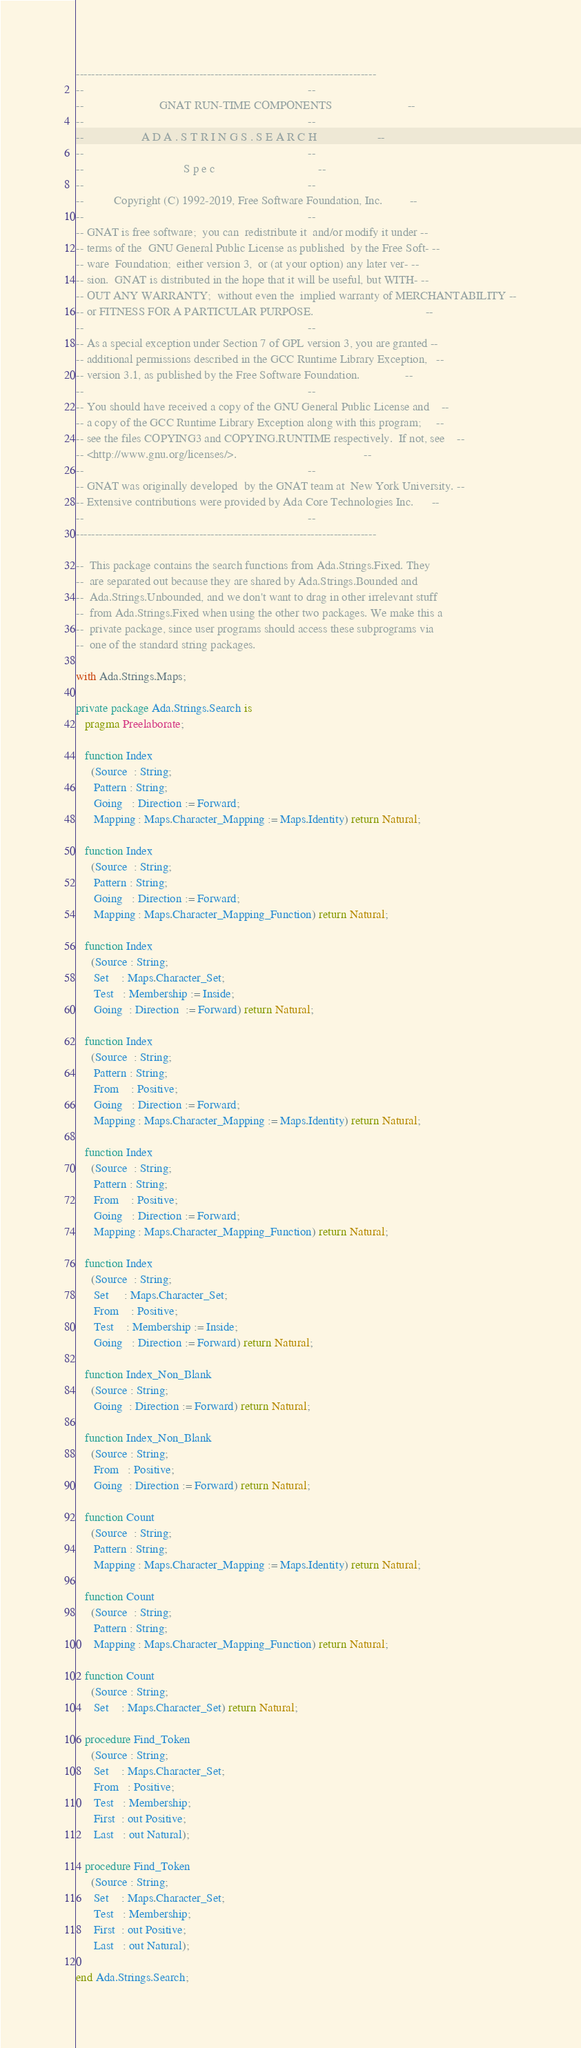Convert code to text. <code><loc_0><loc_0><loc_500><loc_500><_Ada_>------------------------------------------------------------------------------
--                                                                          --
--                         GNAT RUN-TIME COMPONENTS                         --
--                                                                          --
--                   A D A . S T R I N G S . S E A R C H                    --
--                                                                          --
--                                 S p e c                                  --
--                                                                          --
--          Copyright (C) 1992-2019, Free Software Foundation, Inc.         --
--                                                                          --
-- GNAT is free software;  you can  redistribute it  and/or modify it under --
-- terms of the  GNU General Public License as published  by the Free Soft- --
-- ware  Foundation;  either version 3,  or (at your option) any later ver- --
-- sion.  GNAT is distributed in the hope that it will be useful, but WITH- --
-- OUT ANY WARRANTY;  without even the  implied warranty of MERCHANTABILITY --
-- or FITNESS FOR A PARTICULAR PURPOSE.                                     --
--                                                                          --
-- As a special exception under Section 7 of GPL version 3, you are granted --
-- additional permissions described in the GCC Runtime Library Exception,   --
-- version 3.1, as published by the Free Software Foundation.               --
--                                                                          --
-- You should have received a copy of the GNU General Public License and    --
-- a copy of the GCC Runtime Library Exception along with this program;     --
-- see the files COPYING3 and COPYING.RUNTIME respectively.  If not, see    --
-- <http://www.gnu.org/licenses/>.                                          --
--                                                                          --
-- GNAT was originally developed  by the GNAT team at  New York University. --
-- Extensive contributions were provided by Ada Core Technologies Inc.      --
--                                                                          --
------------------------------------------------------------------------------

--  This package contains the search functions from Ada.Strings.Fixed. They
--  are separated out because they are shared by Ada.Strings.Bounded and
--  Ada.Strings.Unbounded, and we don't want to drag in other irrelevant stuff
--  from Ada.Strings.Fixed when using the other two packages. We make this a
--  private package, since user programs should access these subprograms via
--  one of the standard string packages.

with Ada.Strings.Maps;

private package Ada.Strings.Search is
   pragma Preelaborate;

   function Index
     (Source  : String;
      Pattern : String;
      Going   : Direction := Forward;
      Mapping : Maps.Character_Mapping := Maps.Identity) return Natural;

   function Index
     (Source  : String;
      Pattern : String;
      Going   : Direction := Forward;
      Mapping : Maps.Character_Mapping_Function) return Natural;

   function Index
     (Source : String;
      Set    : Maps.Character_Set;
      Test   : Membership := Inside;
      Going  : Direction  := Forward) return Natural;

   function Index
     (Source  : String;
      Pattern : String;
      From    : Positive;
      Going   : Direction := Forward;
      Mapping : Maps.Character_Mapping := Maps.Identity) return Natural;

   function Index
     (Source  : String;
      Pattern : String;
      From    : Positive;
      Going   : Direction := Forward;
      Mapping : Maps.Character_Mapping_Function) return Natural;

   function Index
     (Source  : String;
      Set     : Maps.Character_Set;
      From    : Positive;
      Test    : Membership := Inside;
      Going   : Direction := Forward) return Natural;

   function Index_Non_Blank
     (Source : String;
      Going  : Direction := Forward) return Natural;

   function Index_Non_Blank
     (Source : String;
      From   : Positive;
      Going  : Direction := Forward) return Natural;

   function Count
     (Source  : String;
      Pattern : String;
      Mapping : Maps.Character_Mapping := Maps.Identity) return Natural;

   function Count
     (Source  : String;
      Pattern : String;
      Mapping : Maps.Character_Mapping_Function) return Natural;

   function Count
     (Source : String;
      Set    : Maps.Character_Set) return Natural;

   procedure Find_Token
     (Source : String;
      Set    : Maps.Character_Set;
      From   : Positive;
      Test   : Membership;
      First  : out Positive;
      Last   : out Natural);

   procedure Find_Token
     (Source : String;
      Set    : Maps.Character_Set;
      Test   : Membership;
      First  : out Positive;
      Last   : out Natural);

end Ada.Strings.Search;
</code> 